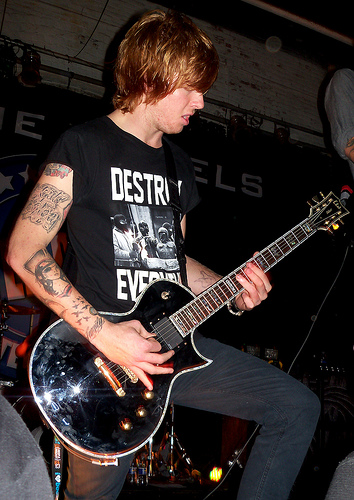<image>
Is the guitar behind the man? No. The guitar is not behind the man. From this viewpoint, the guitar appears to be positioned elsewhere in the scene. 